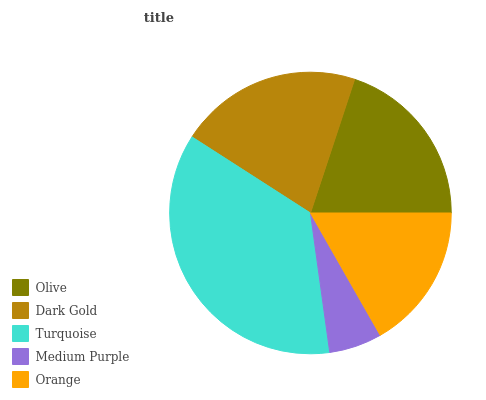Is Medium Purple the minimum?
Answer yes or no. Yes. Is Turquoise the maximum?
Answer yes or no. Yes. Is Dark Gold the minimum?
Answer yes or no. No. Is Dark Gold the maximum?
Answer yes or no. No. Is Dark Gold greater than Olive?
Answer yes or no. Yes. Is Olive less than Dark Gold?
Answer yes or no. Yes. Is Olive greater than Dark Gold?
Answer yes or no. No. Is Dark Gold less than Olive?
Answer yes or no. No. Is Olive the high median?
Answer yes or no. Yes. Is Olive the low median?
Answer yes or no. Yes. Is Medium Purple the high median?
Answer yes or no. No. Is Turquoise the low median?
Answer yes or no. No. 